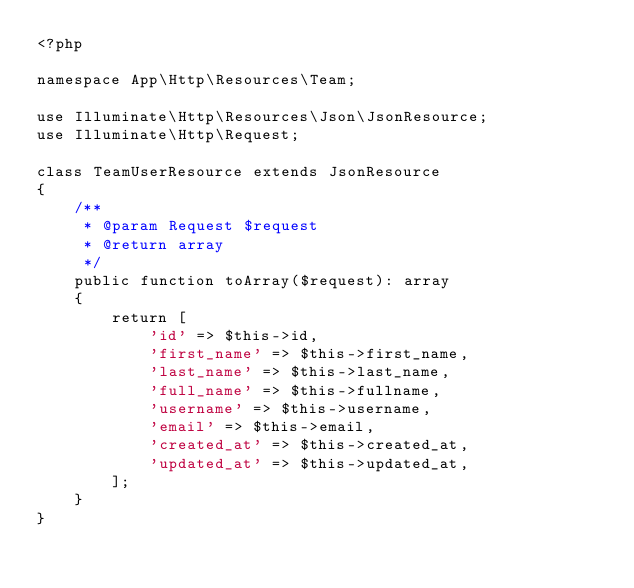<code> <loc_0><loc_0><loc_500><loc_500><_PHP_><?php

namespace App\Http\Resources\Team;

use Illuminate\Http\Resources\Json\JsonResource;
use Illuminate\Http\Request;

class TeamUserResource extends JsonResource
{
    /**
     * @param Request $request
     * @return array
     */
    public function toArray($request): array
    {
        return [
            'id' => $this->id,
            'first_name' => $this->first_name,
            'last_name' => $this->last_name,
            'full_name' => $this->fullname,
            'username' => $this->username,
            'email' => $this->email,
            'created_at' => $this->created_at,
            'updated_at' => $this->updated_at,
        ];
    }
}
</code> 